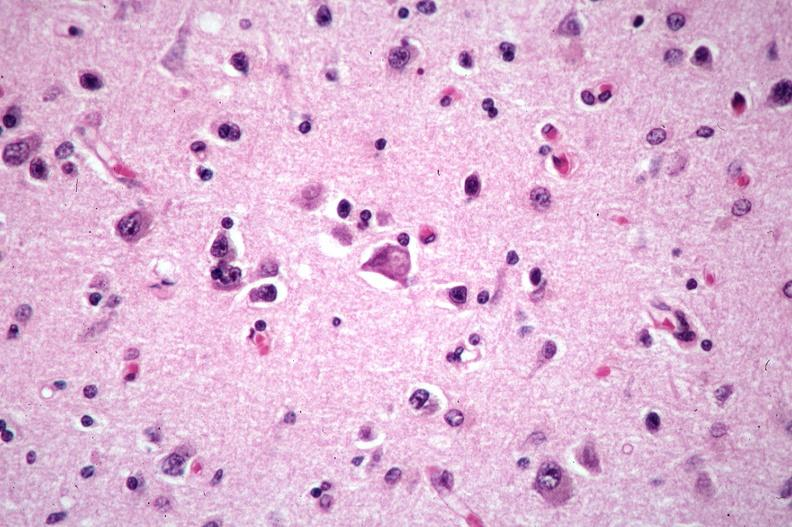does fetus developing very early show brain, pick 's disease?
Answer the question using a single word or phrase. No 